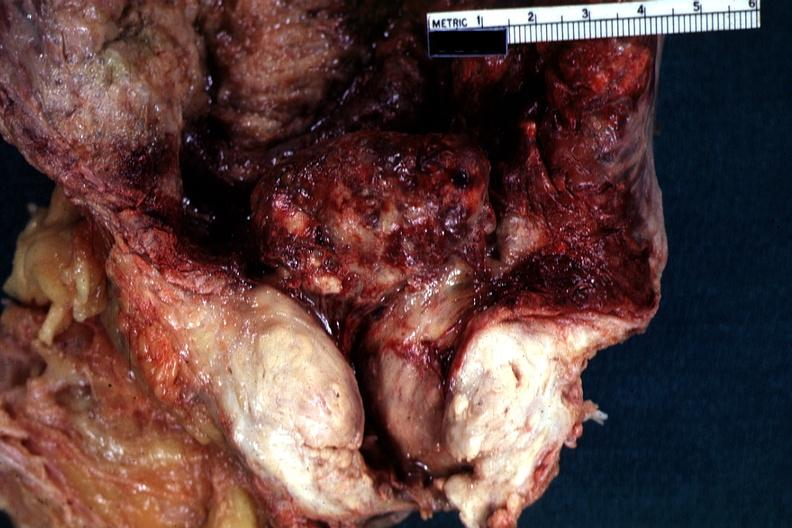how does this image show close-up view of large median bar type lesion?
Answer the question using a single word or phrase. With severe cystitis 